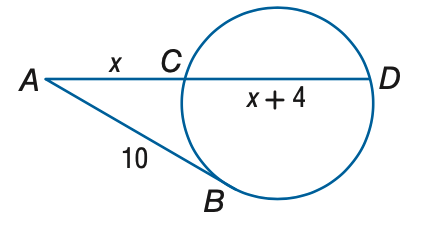Answer the mathemtical geometry problem and directly provide the correct option letter.
Question: A B is tangent to the circle. Find x. Round to the nearest tenth.
Choices: A: 5.1 B: 6.1 C: 7.1 D: 8.1 B 